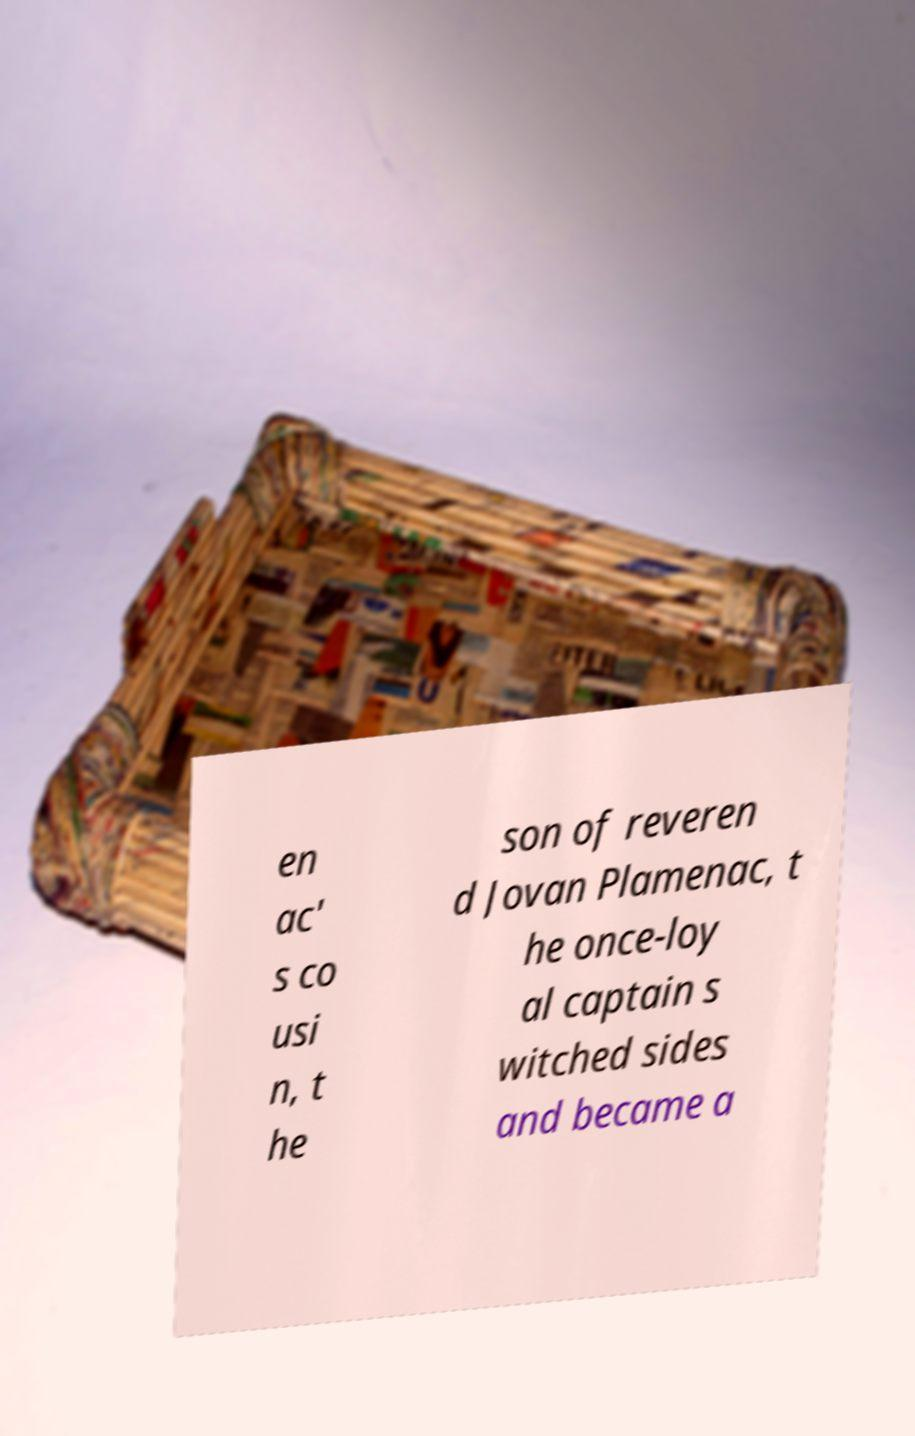Can you read and provide the text displayed in the image?This photo seems to have some interesting text. Can you extract and type it out for me? en ac' s co usi n, t he son of reveren d Jovan Plamenac, t he once-loy al captain s witched sides and became a 